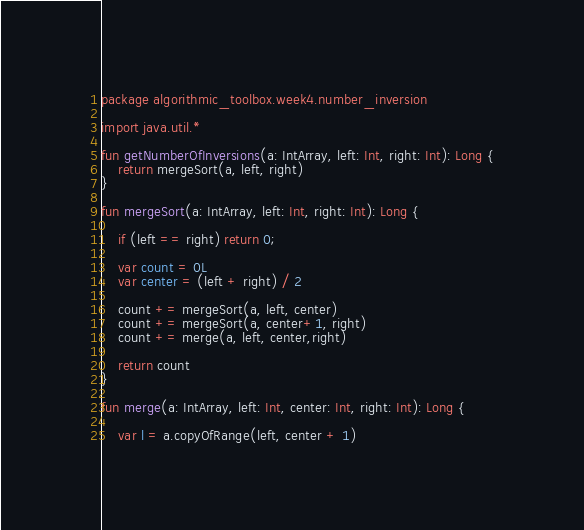<code> <loc_0><loc_0><loc_500><loc_500><_Kotlin_>package algorithmic_toolbox.week4.number_inversion

import java.util.*

fun getNumberOfInversions(a: IntArray, left: Int, right: Int): Long {
    return mergeSort(a, left, right)
}

fun mergeSort(a: IntArray, left: Int, right: Int): Long {

    if (left == right) return 0;

    var count = 0L
    var center = (left + right) / 2

    count += mergeSort(a, left, center)
    count += mergeSort(a, center+1, right)
    count += merge(a, left, center,right)

    return count
}

fun merge(a: IntArray, left: Int, center: Int, right: Int): Long {

    var l = a.copyOfRange(left, center + 1)</code> 